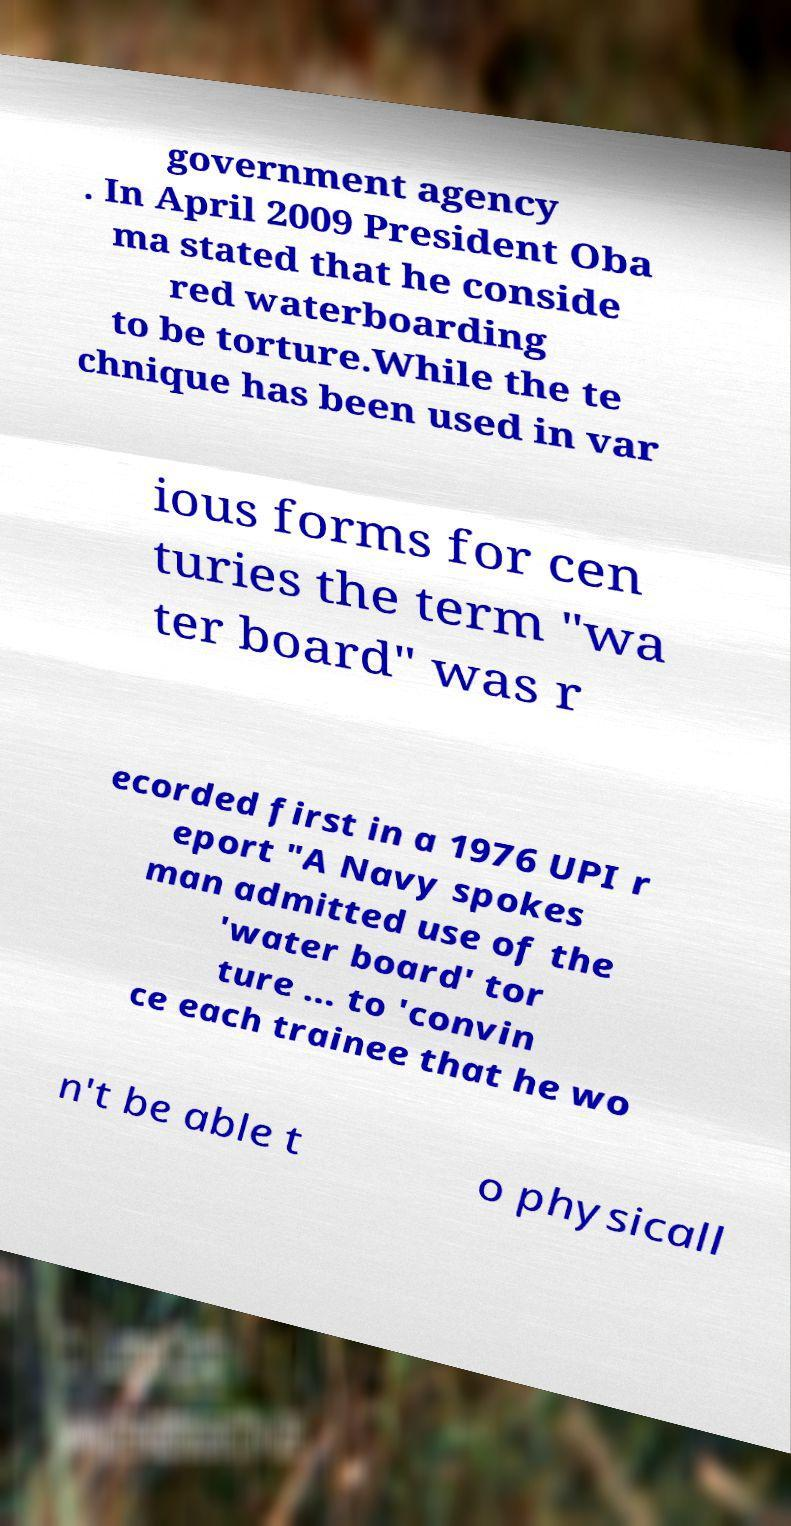For documentation purposes, I need the text within this image transcribed. Could you provide that? government agency . In April 2009 President Oba ma stated that he conside red waterboarding to be torture.While the te chnique has been used in var ious forms for cen turies the term "wa ter board" was r ecorded first in a 1976 UPI r eport "A Navy spokes man admitted use of the 'water board' tor ture ... to 'convin ce each trainee that he wo n't be able t o physicall 